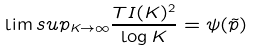<formula> <loc_0><loc_0><loc_500><loc_500>\lim s u p _ { K \rightarrow \infty } \frac { T I ( K ) ^ { 2 } } { \log K } = \psi ( \tilde { p } )</formula> 